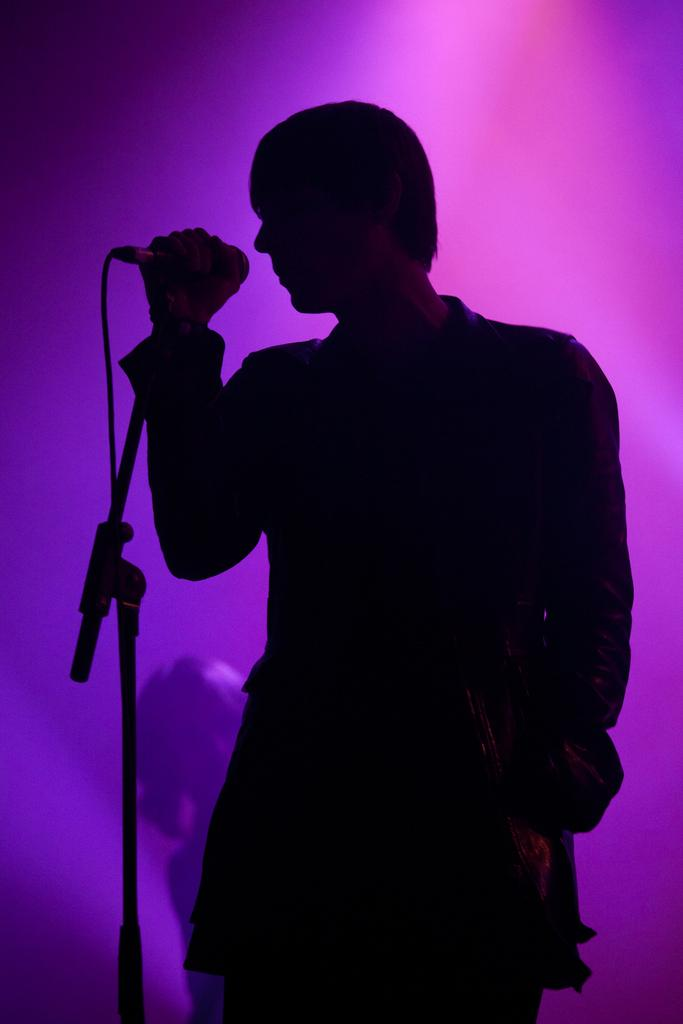What is the man in the image doing? The man is singing in the image. What object is the man holding while singing? The man is holding a microphone. What color is the background of the image? The background color is pink. Can you see the man's tail in the image? There is no tail visible in the image, as the subject is a man. 